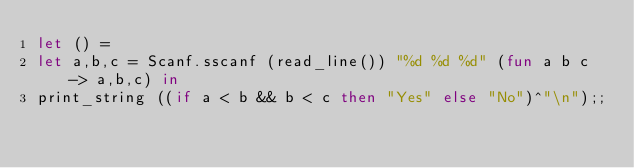Convert code to text. <code><loc_0><loc_0><loc_500><loc_500><_OCaml_>let () =
let a,b,c = Scanf.sscanf (read_line()) "%d %d %d" (fun a b c -> a,b,c) in
print_string ((if a < b && b < c then "Yes" else "No")^"\n");;
</code> 